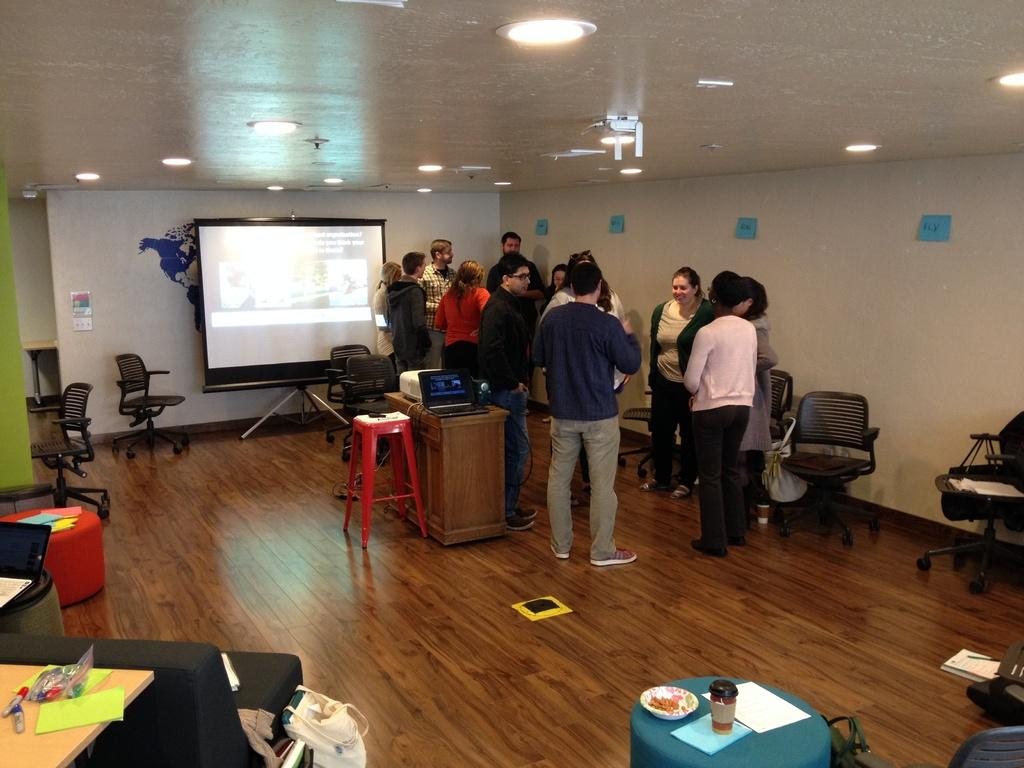What are the people in the image doing? The people in the image are standing in the middle of the room. What furniture is present in the room? There are chairs in the room. What can be seen on the left side of the image? There is a projector screen on the left side of the image. What type of lighting is visible in the image? There are ceiling lights visible at the top of the image. What songs are being sung by the chickens in the image? There are no chickens present in the image, and therefore no songs can be heard. 